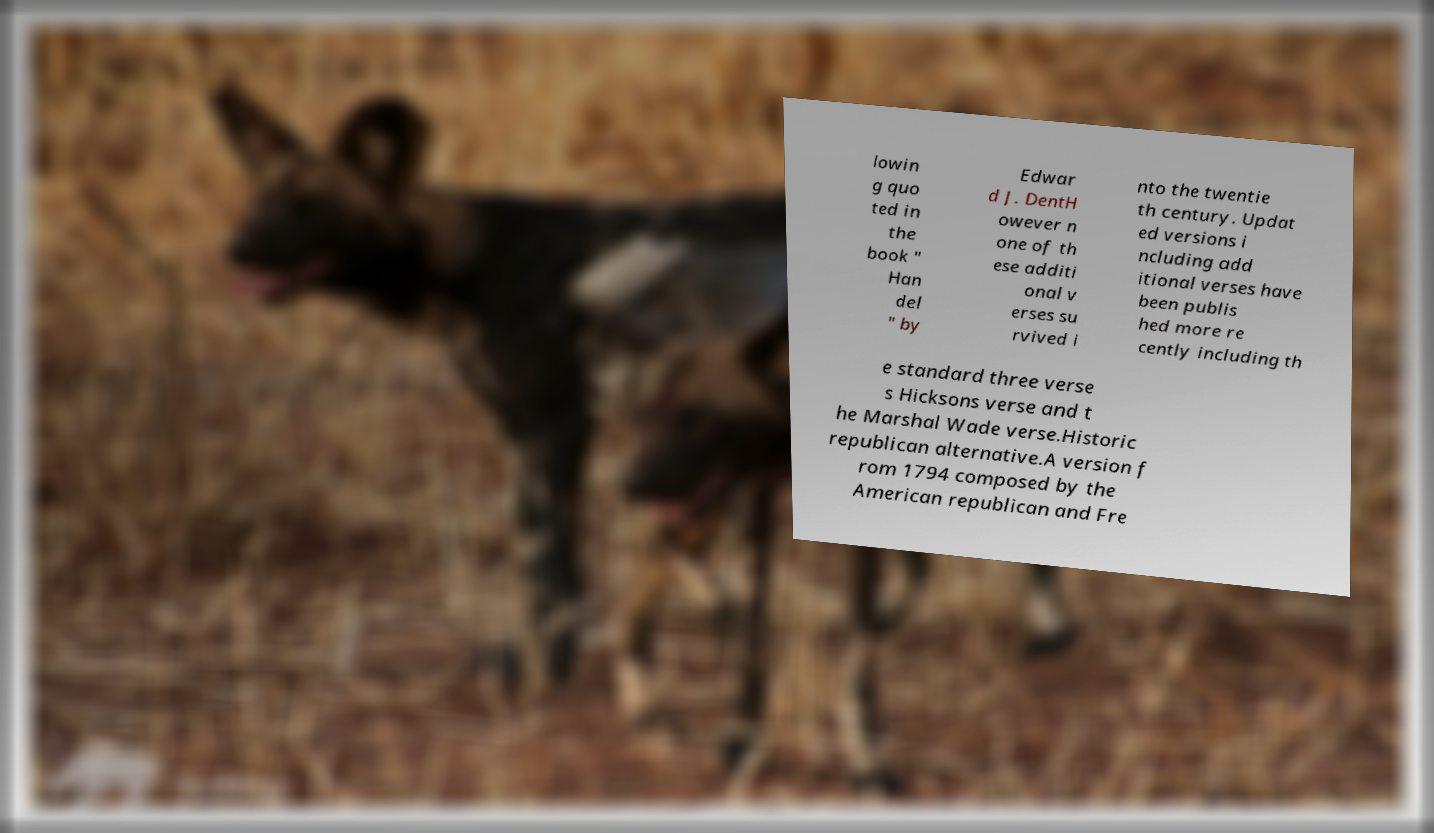Please read and relay the text visible in this image. What does it say? lowin g quo ted in the book " Han del " by Edwar d J. DentH owever n one of th ese additi onal v erses su rvived i nto the twentie th century. Updat ed versions i ncluding add itional verses have been publis hed more re cently including th e standard three verse s Hicksons verse and t he Marshal Wade verse.Historic republican alternative.A version f rom 1794 composed by the American republican and Fre 